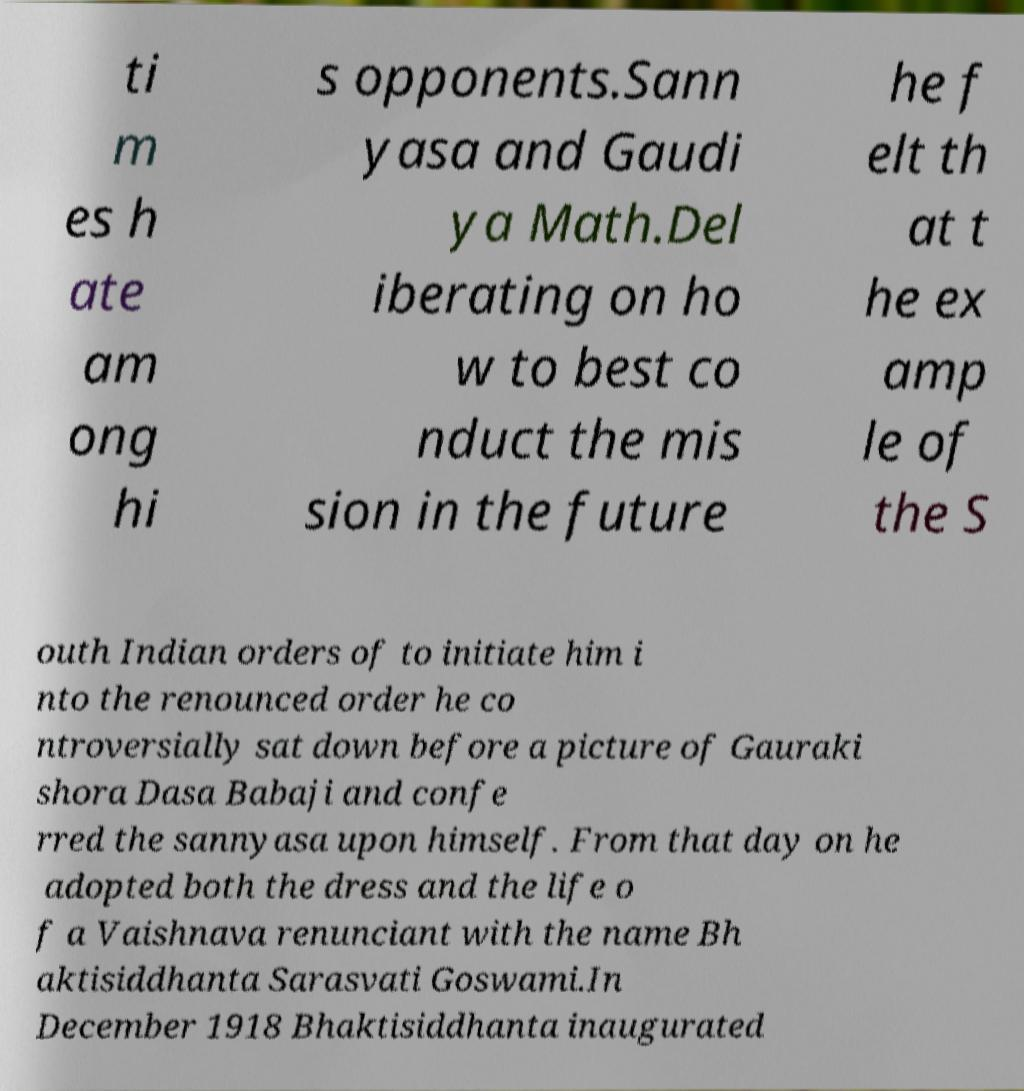What messages or text are displayed in this image? I need them in a readable, typed format. ti m es h ate am ong hi s opponents.Sann yasa and Gaudi ya Math.Del iberating on ho w to best co nduct the mis sion in the future he f elt th at t he ex amp le of the S outh Indian orders of to initiate him i nto the renounced order he co ntroversially sat down before a picture of Gauraki shora Dasa Babaji and confe rred the sannyasa upon himself. From that day on he adopted both the dress and the life o f a Vaishnava renunciant with the name Bh aktisiddhanta Sarasvati Goswami.In December 1918 Bhaktisiddhanta inaugurated 